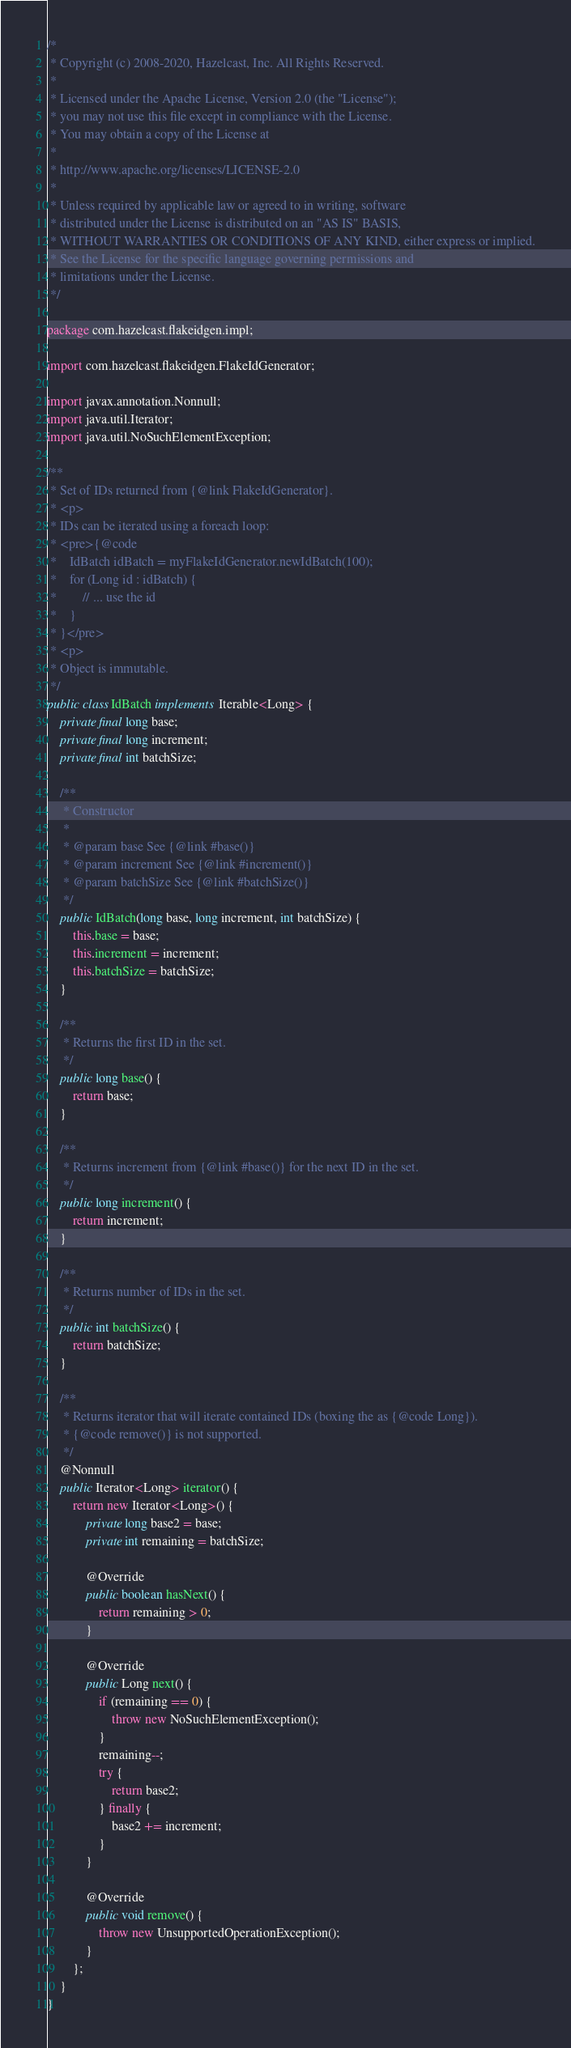<code> <loc_0><loc_0><loc_500><loc_500><_Java_>/*
 * Copyright (c) 2008-2020, Hazelcast, Inc. All Rights Reserved.
 *
 * Licensed under the Apache License, Version 2.0 (the "License");
 * you may not use this file except in compliance with the License.
 * You may obtain a copy of the License at
 *
 * http://www.apache.org/licenses/LICENSE-2.0
 *
 * Unless required by applicable law or agreed to in writing, software
 * distributed under the License is distributed on an "AS IS" BASIS,
 * WITHOUT WARRANTIES OR CONDITIONS OF ANY KIND, either express or implied.
 * See the License for the specific language governing permissions and
 * limitations under the License.
 */

package com.hazelcast.flakeidgen.impl;

import com.hazelcast.flakeidgen.FlakeIdGenerator;

import javax.annotation.Nonnull;
import java.util.Iterator;
import java.util.NoSuchElementException;

/**
 * Set of IDs returned from {@link FlakeIdGenerator}.
 * <p>
 * IDs can be iterated using a foreach loop:
 * <pre>{@code
 *    IdBatch idBatch = myFlakeIdGenerator.newIdBatch(100);
 *    for (Long id : idBatch) {
 *        // ... use the id
 *    }
 * }</pre>
 * <p>
 * Object is immutable.
 */
public class IdBatch implements Iterable<Long> {
    private final long base;
    private final long increment;
    private final int batchSize;

    /**
     * Constructor
     *
     * @param base See {@link #base()}
     * @param increment See {@link #increment()}
     * @param batchSize See {@link #batchSize()}
     */
    public IdBatch(long base, long increment, int batchSize) {
        this.base = base;
        this.increment = increment;
        this.batchSize = batchSize;
    }

    /**
     * Returns the first ID in the set.
     */
    public long base() {
        return base;
    }

    /**
     * Returns increment from {@link #base()} for the next ID in the set.
     */
    public long increment() {
        return increment;
    }

    /**
     * Returns number of IDs in the set.
     */
    public int batchSize() {
        return batchSize;
    }

    /**
     * Returns iterator that will iterate contained IDs (boxing the as {@code Long}).
     * {@code remove()} is not supported.
     */
    @Nonnull
    public Iterator<Long> iterator() {
        return new Iterator<Long>() {
            private long base2 = base;
            private int remaining = batchSize;

            @Override
            public boolean hasNext() {
                return remaining > 0;
            }

            @Override
            public Long next() {
                if (remaining == 0) {
                    throw new NoSuchElementException();
                }
                remaining--;
                try {
                    return base2;
                } finally {
                    base2 += increment;
                }
            }

            @Override
            public void remove() {
                throw new UnsupportedOperationException();
            }
        };
    }
}
</code> 